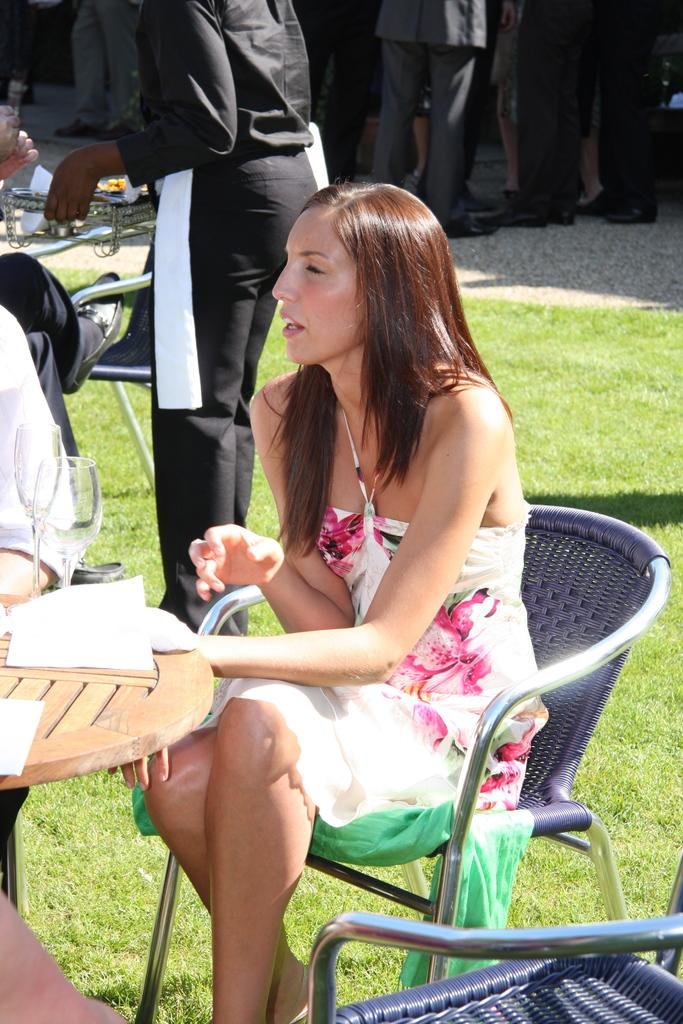What is the woman in the image doing? The woman is seated on a chair in the image. What is located in front of the woman? There is a table in front of the woman. What is the person in the image doing? The person is standing and serving food in the image. What is the best route to reach the thoughtful berry in the image? There is no mention of a berry or a route in the image, so this question cannot be answered. 